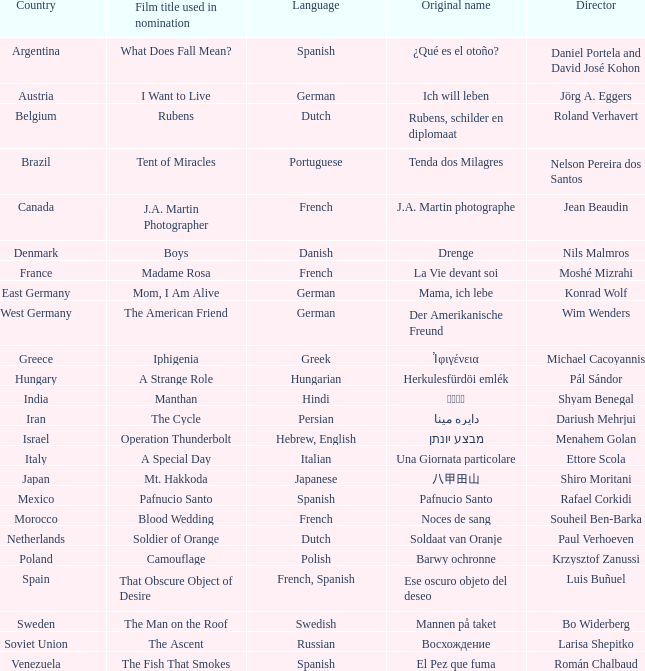In which country was the movie tent of miracles produced? Brazil. 